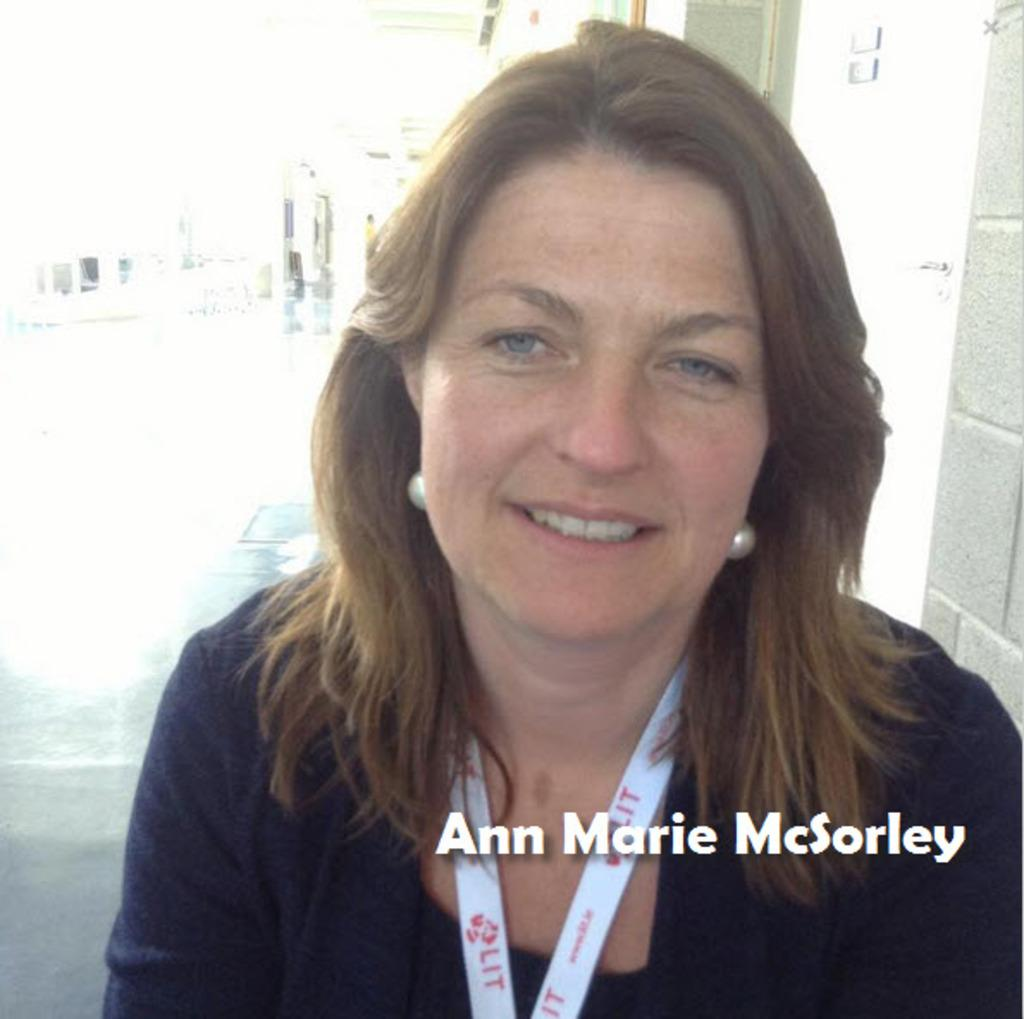Who is present in the image? There is a woman in the image. What is the woman wearing around her neck? The woman is wearing something white around her neck. Is there any indication of the image's origin or ownership? Yes, there is a watermark in the image. What can be seen in the background of the image? There is a wall visible in the background of the image. What type of prose can be heard being read by the woman in the image? There is no indication in the image that the woman is reading or speaking, so it cannot be determined if any prose is being read. 